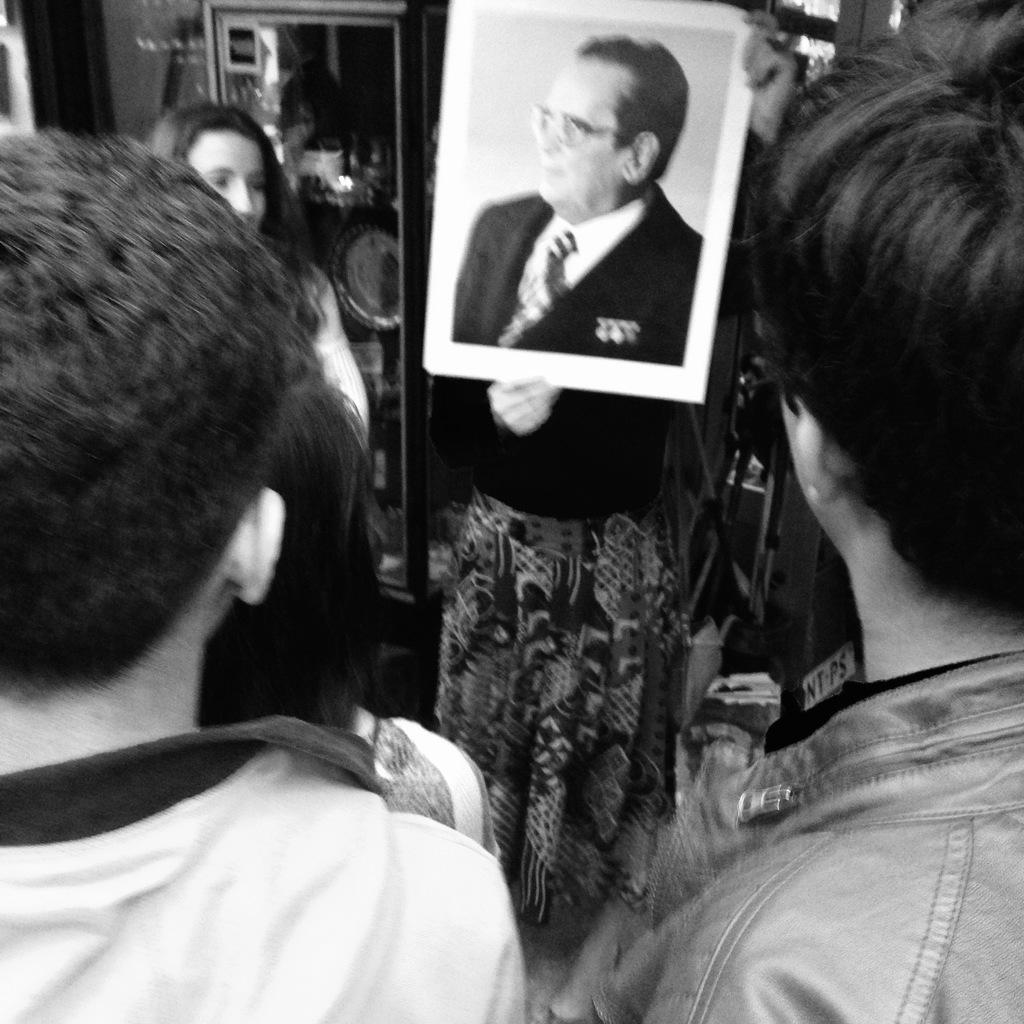How many people are in the image? There is a group of people in the image. What is one person holding in the image? One person is holding a photo of a poster. What can be seen in the background of the image? There is a mirror and a wall in the background of the image, along with other objects. What type of twig is being used for the operation in the image? There is no operation or twig present in the image. 